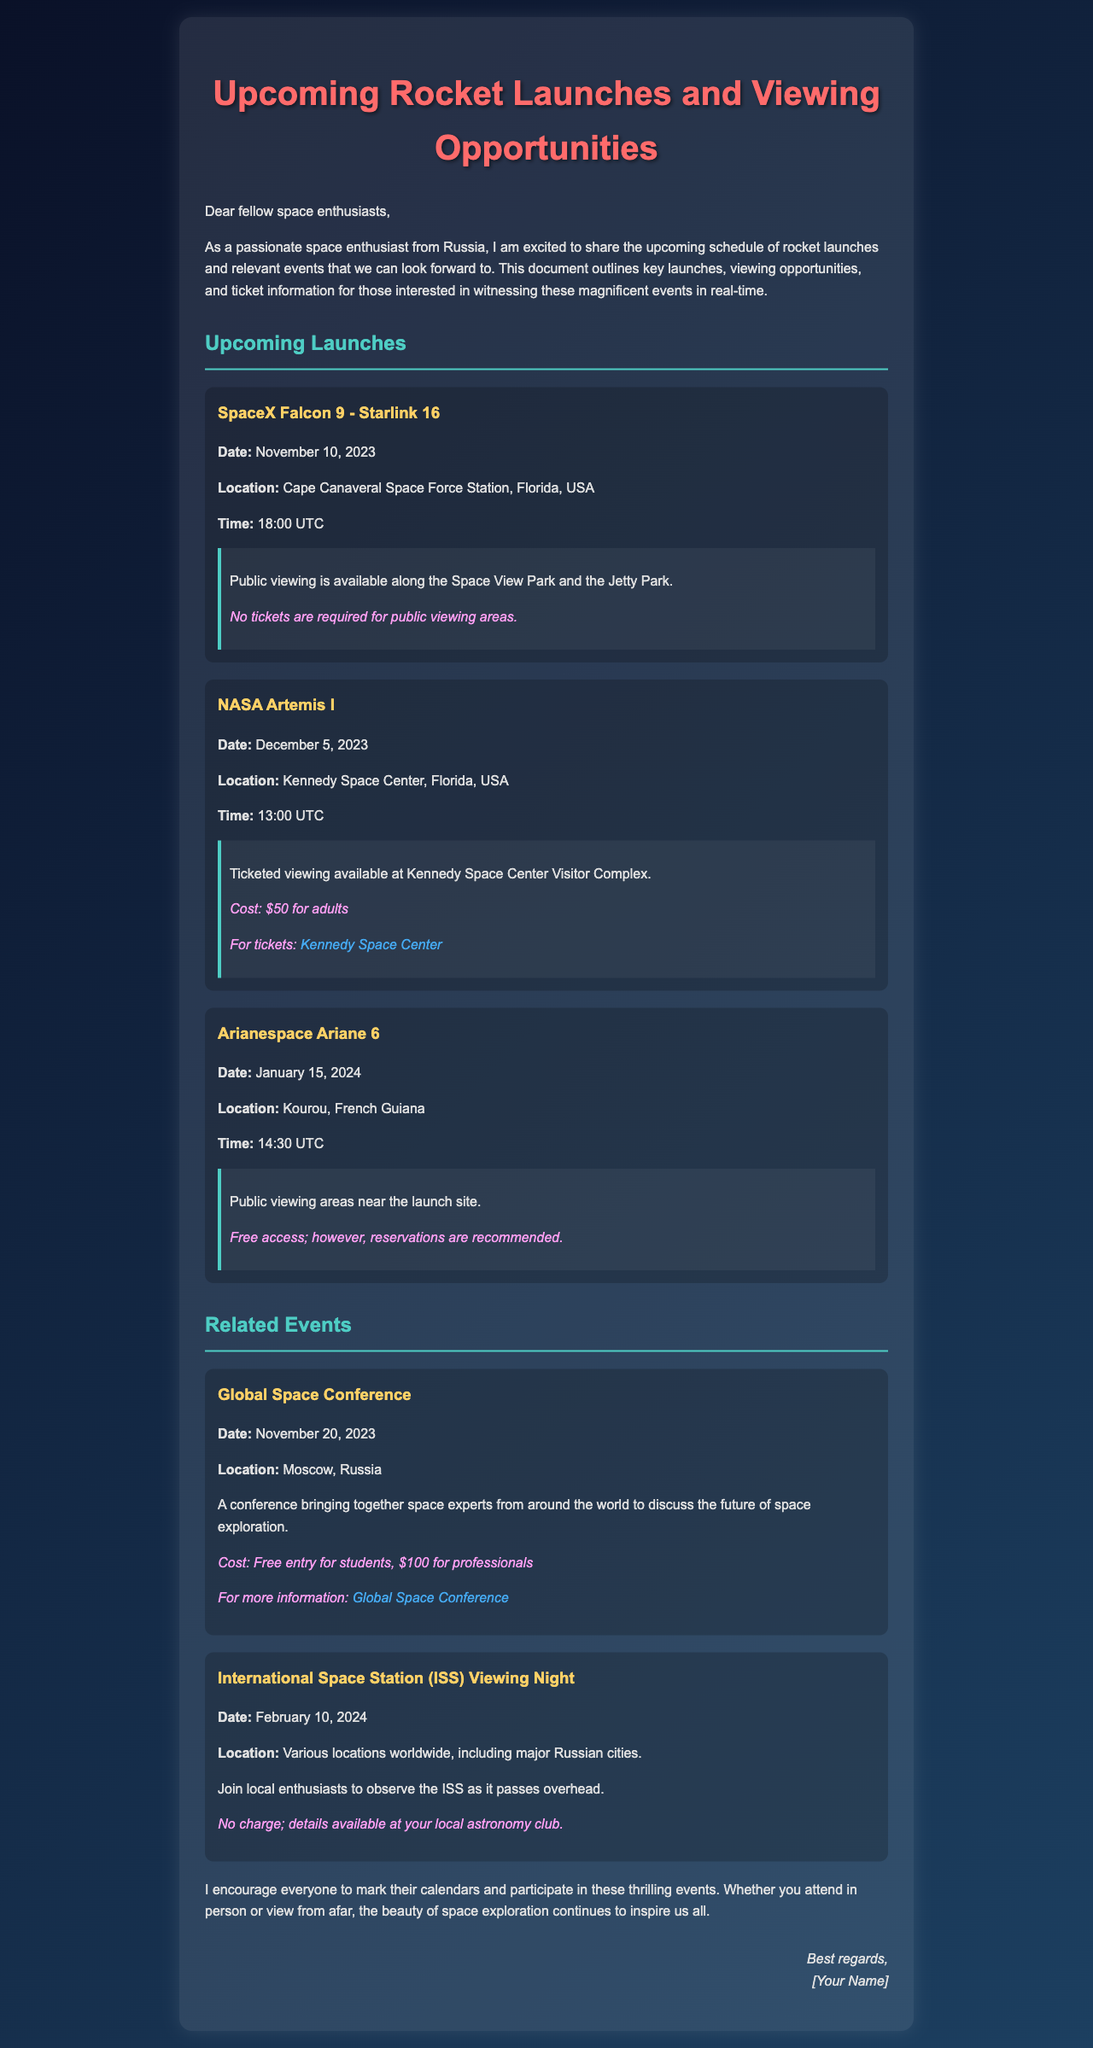What is the date of the SpaceX Falcon 9 launch? The document specifies the launch date for SpaceX Falcon 9 as November 10, 2023.
Answer: November 10, 2023 Where is the NASA Artemis I launch taking place? The document states that NASA Artemis I will be launched from Kennedy Space Center, Florida, USA.
Answer: Kennedy Space Center, Florida, USA What is the ticket price for adults at the Kennedy Space Center Visitor Complex? The document indicates that the cost for adults to attend the NASA Artemis I launch is $50.
Answer: $50 When is the Global Space Conference scheduled? The document mentions the date for the Global Space Conference as November 20, 2023.
Answer: November 20, 2023 What type of viewing is available for the Arianespace Ariane 6 launch? The document describes public viewing areas for the Arianespace Ariane 6 launch.
Answer: Public viewing areas What is the cost for professionals to attend the Global Space Conference? The document specifies that the cost for professionals to attend the Global Space Conference is $100.
Answer: $100 How much time before the launch is the SpaceX Falcon 9 scheduled? The document states that the SpaceX Falcon 9 is set to launch at 18:00 UTC.
Answer: 18:00 UTC Is a ticket required for the ISS Viewing Night? The document indicates that no charge is required for the ISS Viewing Night.
Answer: No charge What is the viewing location for the ISS Viewing Night event? The document states that the viewing will take place at various locations worldwide, including major Russian cities.
Answer: Various locations worldwide, including major Russian cities 